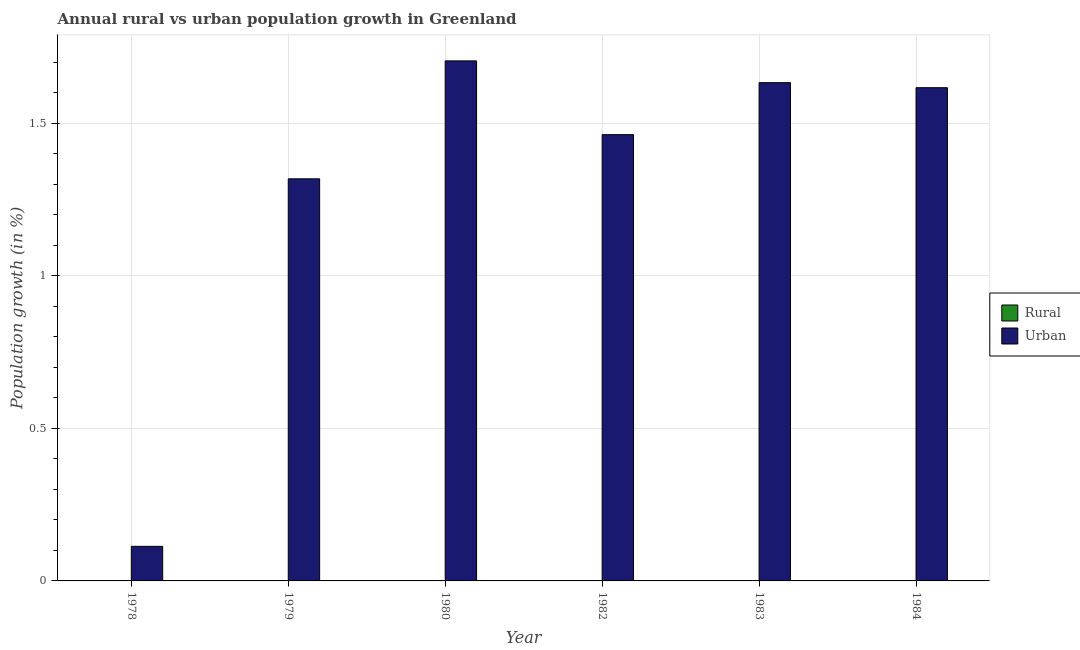How many different coloured bars are there?
Your response must be concise. 1. How many bars are there on the 3rd tick from the right?
Provide a short and direct response. 1. What is the urban population growth in 1982?
Make the answer very short. 1.46. Across all years, what is the maximum urban population growth?
Offer a very short reply. 1.7. Across all years, what is the minimum rural population growth?
Your response must be concise. 0. What is the total urban population growth in the graph?
Offer a very short reply. 7.85. What is the difference between the urban population growth in 1983 and that in 1984?
Keep it short and to the point. 0.02. What is the difference between the urban population growth in 1978 and the rural population growth in 1979?
Give a very brief answer. -1.2. What is the average rural population growth per year?
Ensure brevity in your answer.  0. What is the ratio of the urban population growth in 1980 to that in 1983?
Your answer should be compact. 1.04. What is the difference between the highest and the second highest urban population growth?
Ensure brevity in your answer.  0.07. What is the difference between the highest and the lowest urban population growth?
Keep it short and to the point. 1.59. Is the sum of the urban population growth in 1978 and 1984 greater than the maximum rural population growth across all years?
Ensure brevity in your answer.  Yes. How many bars are there?
Make the answer very short. 6. How many years are there in the graph?
Make the answer very short. 6. Are the values on the major ticks of Y-axis written in scientific E-notation?
Your answer should be compact. No. Where does the legend appear in the graph?
Your answer should be very brief. Center right. How many legend labels are there?
Keep it short and to the point. 2. How are the legend labels stacked?
Give a very brief answer. Vertical. What is the title of the graph?
Your answer should be very brief. Annual rural vs urban population growth in Greenland. What is the label or title of the Y-axis?
Your answer should be compact. Population growth (in %). What is the Population growth (in %) in Rural in 1978?
Your answer should be compact. 0. What is the Population growth (in %) in Urban  in 1978?
Make the answer very short. 0.11. What is the Population growth (in %) of Rural in 1979?
Give a very brief answer. 0. What is the Population growth (in %) of Urban  in 1979?
Make the answer very short. 1.32. What is the Population growth (in %) of Urban  in 1980?
Offer a terse response. 1.7. What is the Population growth (in %) of Urban  in 1982?
Make the answer very short. 1.46. What is the Population growth (in %) of Urban  in 1983?
Give a very brief answer. 1.63. What is the Population growth (in %) of Urban  in 1984?
Ensure brevity in your answer.  1.62. Across all years, what is the maximum Population growth (in %) in Urban ?
Your answer should be compact. 1.7. Across all years, what is the minimum Population growth (in %) in Urban ?
Your response must be concise. 0.11. What is the total Population growth (in %) in Rural in the graph?
Offer a very short reply. 0. What is the total Population growth (in %) of Urban  in the graph?
Your answer should be very brief. 7.85. What is the difference between the Population growth (in %) of Urban  in 1978 and that in 1979?
Provide a short and direct response. -1.21. What is the difference between the Population growth (in %) of Urban  in 1978 and that in 1980?
Ensure brevity in your answer.  -1.59. What is the difference between the Population growth (in %) in Urban  in 1978 and that in 1982?
Offer a terse response. -1.35. What is the difference between the Population growth (in %) in Urban  in 1978 and that in 1983?
Provide a succinct answer. -1.52. What is the difference between the Population growth (in %) of Urban  in 1978 and that in 1984?
Offer a very short reply. -1.5. What is the difference between the Population growth (in %) of Urban  in 1979 and that in 1980?
Provide a short and direct response. -0.39. What is the difference between the Population growth (in %) in Urban  in 1979 and that in 1982?
Your response must be concise. -0.14. What is the difference between the Population growth (in %) of Urban  in 1979 and that in 1983?
Give a very brief answer. -0.32. What is the difference between the Population growth (in %) in Urban  in 1979 and that in 1984?
Ensure brevity in your answer.  -0.3. What is the difference between the Population growth (in %) of Urban  in 1980 and that in 1982?
Your answer should be compact. 0.24. What is the difference between the Population growth (in %) of Urban  in 1980 and that in 1983?
Your answer should be compact. 0.07. What is the difference between the Population growth (in %) in Urban  in 1980 and that in 1984?
Provide a succinct answer. 0.09. What is the difference between the Population growth (in %) of Urban  in 1982 and that in 1983?
Your response must be concise. -0.17. What is the difference between the Population growth (in %) in Urban  in 1982 and that in 1984?
Offer a very short reply. -0.15. What is the difference between the Population growth (in %) in Urban  in 1983 and that in 1984?
Keep it short and to the point. 0.02. What is the average Population growth (in %) of Urban  per year?
Ensure brevity in your answer.  1.31. What is the ratio of the Population growth (in %) of Urban  in 1978 to that in 1979?
Make the answer very short. 0.09. What is the ratio of the Population growth (in %) of Urban  in 1978 to that in 1980?
Your response must be concise. 0.07. What is the ratio of the Population growth (in %) in Urban  in 1978 to that in 1982?
Keep it short and to the point. 0.08. What is the ratio of the Population growth (in %) of Urban  in 1978 to that in 1983?
Your response must be concise. 0.07. What is the ratio of the Population growth (in %) of Urban  in 1978 to that in 1984?
Your answer should be very brief. 0.07. What is the ratio of the Population growth (in %) in Urban  in 1979 to that in 1980?
Give a very brief answer. 0.77. What is the ratio of the Population growth (in %) of Urban  in 1979 to that in 1982?
Offer a terse response. 0.9. What is the ratio of the Population growth (in %) in Urban  in 1979 to that in 1983?
Make the answer very short. 0.81. What is the ratio of the Population growth (in %) of Urban  in 1979 to that in 1984?
Your answer should be compact. 0.82. What is the ratio of the Population growth (in %) of Urban  in 1980 to that in 1982?
Your answer should be very brief. 1.17. What is the ratio of the Population growth (in %) in Urban  in 1980 to that in 1983?
Provide a short and direct response. 1.04. What is the ratio of the Population growth (in %) of Urban  in 1980 to that in 1984?
Offer a very short reply. 1.05. What is the ratio of the Population growth (in %) of Urban  in 1982 to that in 1983?
Offer a very short reply. 0.9. What is the ratio of the Population growth (in %) in Urban  in 1982 to that in 1984?
Make the answer very short. 0.9. What is the ratio of the Population growth (in %) of Urban  in 1983 to that in 1984?
Give a very brief answer. 1.01. What is the difference between the highest and the second highest Population growth (in %) of Urban ?
Your answer should be very brief. 0.07. What is the difference between the highest and the lowest Population growth (in %) of Urban ?
Your answer should be compact. 1.59. 